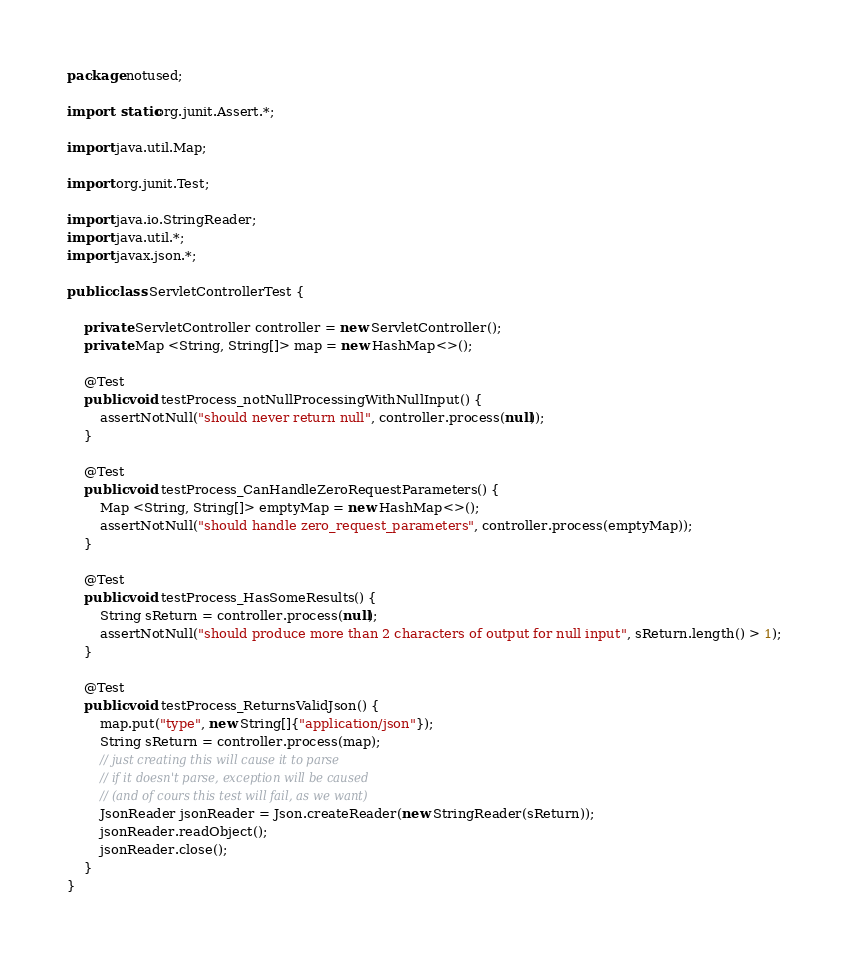Convert code to text. <code><loc_0><loc_0><loc_500><loc_500><_Java_>package notused;

import static org.junit.Assert.*;

import java.util.Map;

import org.junit.Test;

import java.io.StringReader;
import java.util.*;
import javax.json.*;

public class ServletControllerTest {
	
	private ServletController controller = new ServletController();
	private Map <String, String[]> map = new HashMap<>();

	@Test
	public void testProcess_notNullProcessingWithNullInput() {
		assertNotNull("should never return null", controller.process(null));
	}
	
	@Test
	public void testProcess_CanHandleZeroRequestParameters() {
		Map <String, String[]> emptyMap = new HashMap<>();
		assertNotNull("should handle zero_request_parameters", controller.process(emptyMap));
	}

	@Test
	public void testProcess_HasSomeResults() {
		String sReturn = controller.process(null);
		assertNotNull("should produce more than 2 characters of output for null input", sReturn.length() > 1);
	}
	
	@Test
	public void testProcess_ReturnsValidJson() {
		map.put("type", new String[]{"application/json"});
		String sReturn = controller.process(map);
		// just creating this will cause it to parse
		// if it doesn't parse, exception will be caused
		// (and of cours this test will fail, as we want)
		JsonReader jsonReader = Json.createReader(new StringReader(sReturn));
		jsonReader.readObject();
		jsonReader.close();
	}
}
</code> 